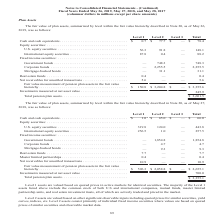According to Conagra Brands's financial document, What are Level 2 assets primarily consist of? individual fixed income securities where values are based on quoted prices of similar securities and observable market data. The document states: "indices, etc. Level 2 assets consist primarily of individual fixed income securities where values are based on quoted prices of similar securities and..." Also, What are Level 3 assets consist of? Based on the financial document, the answer is investments where active market pricing is not readily available and, as such, fair value is estimated using significant unobservable inputs. Also, What are the fair values of Level 2 government bonds and corporate bonds, respectively? The document shows two values: 1,854.8 and 4.7 (in millions). From the document: "Corporate bonds . — 4.7 — 4.7 Government bonds . — 1,854.8 — 1,854.8..." Also, can you calculate: What is the proportion of equity securities over the total fair value measurement of pension plan assets of Level 1 assets? To answer this question, I need to perform calculations using the financial data. The calculation is: (319.8+256.5)/596.3 , which equals 0.97. This is based on the information: "U.S. equity securities . 319.8 124.0 — 443.8 nsion plan assets in the fair value hierarchy . $ 596.3 $ 2,058.8 $ — $ 2,655.1 International equity securities . 256.5 1.0 — 257.5..." The key data points involved are: 256.5, 319.8, 596.3. Additionally, Which fixed income securities have the highest fair value? According to the financial document, Government bonds. The relevant text states: "Government bonds . — 1,854.8 — 1,854.8..." Also, can you calculate: What is the proportion (in percentage) of real estate funds and master limited partnerships over the total pension plan assets? To answer this question, I need to perform calculations using the financial data. The calculation is: (7.7+0.4)/3,355.1 , which equals 0.24 (percentage). This is based on the information: "Total pension plan assets. . $ 3,355.1 Real estate funds . 7.7 — — 7.7 Master limited partnerships . 0.4 — — 0.4..." The key data points involved are: 0.4, 3,355.1, 7.7. 